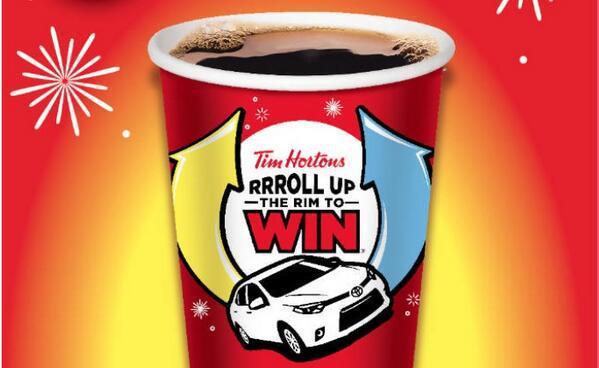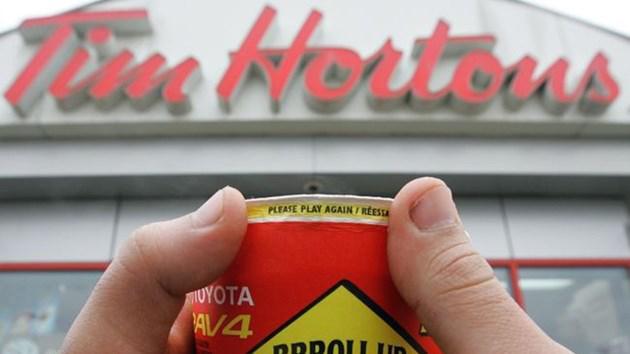The first image is the image on the left, the second image is the image on the right. For the images shown, is this caption "There are two red cups with one being held by a hand." true? Answer yes or no. Yes. The first image is the image on the left, the second image is the image on the right. Considering the images on both sides, is "A person is holding a cup in one of the images." valid? Answer yes or no. Yes. 